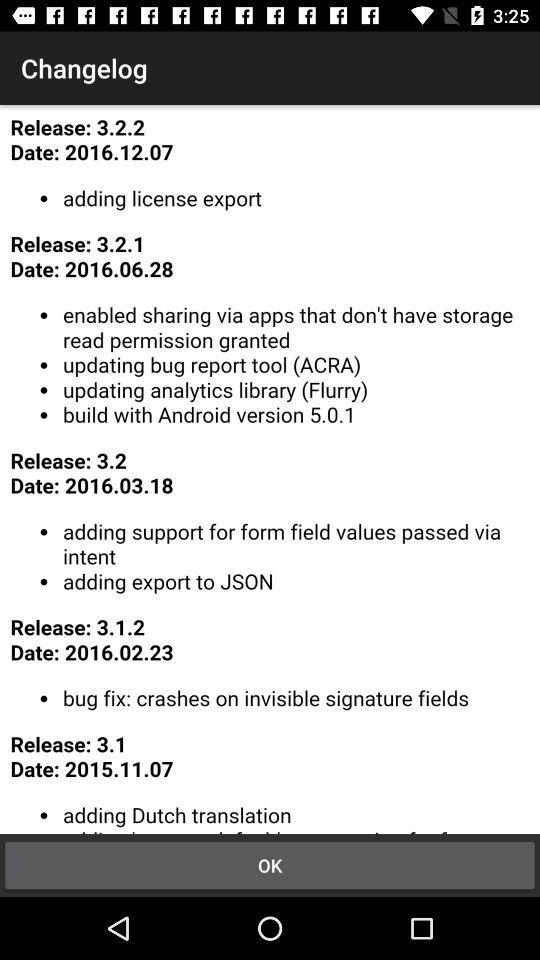What are the new changes in latest "Release"? The new changes "adding license export". 